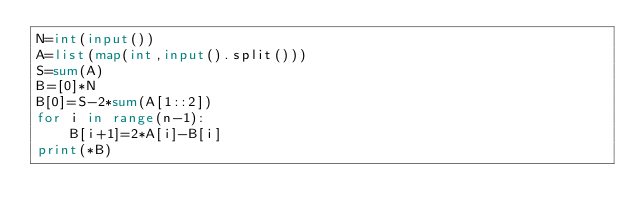Convert code to text. <code><loc_0><loc_0><loc_500><loc_500><_Python_>N=int(input())
A=list(map(int,input().split()))
S=sum(A)
B=[0]*N
B[0]=S-2*sum(A[1::2])
for i in range(n-1):
    B[i+1]=2*A[i]-B[i]
print(*B)</code> 